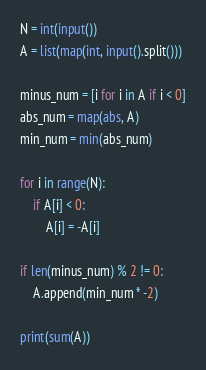Convert code to text. <code><loc_0><loc_0><loc_500><loc_500><_Python_>N = int(input())
A = list(map(int, input().split()))

minus_num = [i for i in A if i < 0]
abs_num = map(abs, A)
min_num = min(abs_num)

for i in range(N):
    if A[i] < 0:
        A[i] = -A[i]

if len(minus_num) % 2 != 0:
    A.append(min_num * -2)

print(sum(A))
</code> 